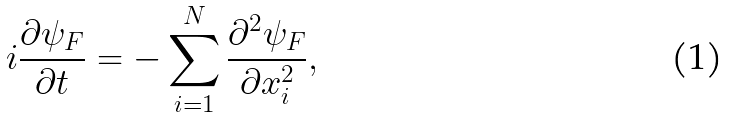Convert formula to latex. <formula><loc_0><loc_0><loc_500><loc_500>i \frac { \partial \psi _ { F } } { \partial t } = - \sum _ { i = 1 } ^ { N } \frac { \partial ^ { 2 } \psi _ { F } } { \partial x _ { i } ^ { 2 } } ,</formula> 